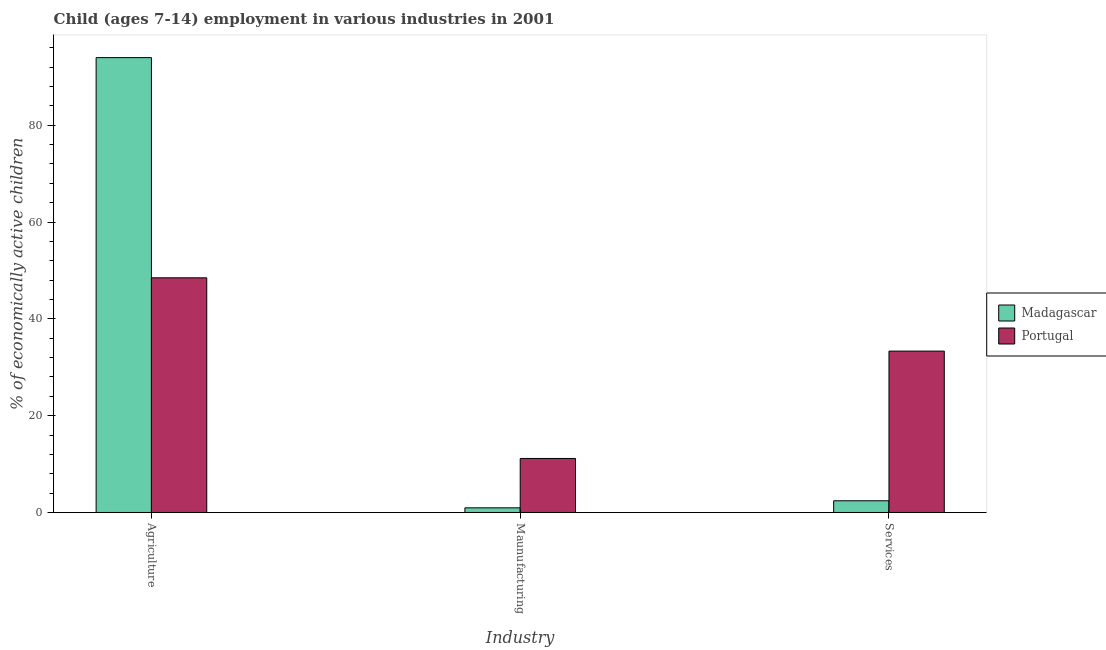How many different coloured bars are there?
Ensure brevity in your answer.  2. How many groups of bars are there?
Your response must be concise. 3. Are the number of bars per tick equal to the number of legend labels?
Provide a short and direct response. Yes. Are the number of bars on each tick of the X-axis equal?
Your answer should be very brief. Yes. How many bars are there on the 1st tick from the right?
Provide a succinct answer. 2. What is the label of the 3rd group of bars from the left?
Keep it short and to the point. Services. What is the percentage of economically active children in services in Madagascar?
Provide a succinct answer. 2.42. Across all countries, what is the maximum percentage of economically active children in manufacturing?
Provide a succinct answer. 11.16. Across all countries, what is the minimum percentage of economically active children in agriculture?
Offer a terse response. 48.48. In which country was the percentage of economically active children in manufacturing maximum?
Your response must be concise. Portugal. In which country was the percentage of economically active children in services minimum?
Your answer should be compact. Madagascar. What is the total percentage of economically active children in manufacturing in the graph?
Your answer should be compact. 12.12. What is the difference between the percentage of economically active children in agriculture in Portugal and that in Madagascar?
Give a very brief answer. -45.49. What is the difference between the percentage of economically active children in services in Madagascar and the percentage of economically active children in agriculture in Portugal?
Ensure brevity in your answer.  -46.06. What is the average percentage of economically active children in manufacturing per country?
Your response must be concise. 6.06. What is the difference between the percentage of economically active children in agriculture and percentage of economically active children in services in Portugal?
Give a very brief answer. 15.14. In how many countries, is the percentage of economically active children in manufacturing greater than 80 %?
Your response must be concise. 0. What is the ratio of the percentage of economically active children in manufacturing in Portugal to that in Madagascar?
Give a very brief answer. 11.62. What is the difference between the highest and the second highest percentage of economically active children in agriculture?
Provide a short and direct response. 45.49. What is the difference between the highest and the lowest percentage of economically active children in services?
Keep it short and to the point. 30.92. Is the sum of the percentage of economically active children in agriculture in Madagascar and Portugal greater than the maximum percentage of economically active children in services across all countries?
Offer a very short reply. Yes. What does the 2nd bar from the left in Maunufacturing represents?
Provide a short and direct response. Portugal. What does the 2nd bar from the right in Agriculture represents?
Make the answer very short. Madagascar. How many bars are there?
Give a very brief answer. 6. Are all the bars in the graph horizontal?
Your answer should be compact. No. What is the difference between two consecutive major ticks on the Y-axis?
Your answer should be compact. 20. Are the values on the major ticks of Y-axis written in scientific E-notation?
Give a very brief answer. No. Does the graph contain any zero values?
Provide a short and direct response. No. Does the graph contain grids?
Give a very brief answer. No. Where does the legend appear in the graph?
Provide a short and direct response. Center right. How many legend labels are there?
Keep it short and to the point. 2. What is the title of the graph?
Offer a very short reply. Child (ages 7-14) employment in various industries in 2001. What is the label or title of the X-axis?
Your answer should be very brief. Industry. What is the label or title of the Y-axis?
Provide a short and direct response. % of economically active children. What is the % of economically active children of Madagascar in Agriculture?
Offer a very short reply. 93.97. What is the % of economically active children of Portugal in Agriculture?
Your answer should be very brief. 48.48. What is the % of economically active children of Portugal in Maunufacturing?
Your response must be concise. 11.16. What is the % of economically active children in Madagascar in Services?
Make the answer very short. 2.42. What is the % of economically active children of Portugal in Services?
Your answer should be compact. 33.34. Across all Industry, what is the maximum % of economically active children of Madagascar?
Give a very brief answer. 93.97. Across all Industry, what is the maximum % of economically active children in Portugal?
Make the answer very short. 48.48. Across all Industry, what is the minimum % of economically active children of Portugal?
Your response must be concise. 11.16. What is the total % of economically active children of Madagascar in the graph?
Ensure brevity in your answer.  97.35. What is the total % of economically active children of Portugal in the graph?
Provide a short and direct response. 92.98. What is the difference between the % of economically active children of Madagascar in Agriculture and that in Maunufacturing?
Give a very brief answer. 93.01. What is the difference between the % of economically active children of Portugal in Agriculture and that in Maunufacturing?
Provide a short and direct response. 37.32. What is the difference between the % of economically active children in Madagascar in Agriculture and that in Services?
Offer a terse response. 91.55. What is the difference between the % of economically active children of Portugal in Agriculture and that in Services?
Give a very brief answer. 15.14. What is the difference between the % of economically active children of Madagascar in Maunufacturing and that in Services?
Your answer should be compact. -1.46. What is the difference between the % of economically active children in Portugal in Maunufacturing and that in Services?
Your response must be concise. -22.18. What is the difference between the % of economically active children in Madagascar in Agriculture and the % of economically active children in Portugal in Maunufacturing?
Your answer should be very brief. 82.81. What is the difference between the % of economically active children of Madagascar in Agriculture and the % of economically active children of Portugal in Services?
Provide a succinct answer. 60.63. What is the difference between the % of economically active children of Madagascar in Maunufacturing and the % of economically active children of Portugal in Services?
Offer a terse response. -32.38. What is the average % of economically active children in Madagascar per Industry?
Give a very brief answer. 32.45. What is the average % of economically active children in Portugal per Industry?
Keep it short and to the point. 30.99. What is the difference between the % of economically active children in Madagascar and % of economically active children in Portugal in Agriculture?
Your answer should be compact. 45.49. What is the difference between the % of economically active children in Madagascar and % of economically active children in Portugal in Maunufacturing?
Offer a terse response. -10.2. What is the difference between the % of economically active children of Madagascar and % of economically active children of Portugal in Services?
Offer a terse response. -30.92. What is the ratio of the % of economically active children in Madagascar in Agriculture to that in Maunufacturing?
Offer a terse response. 97.89. What is the ratio of the % of economically active children in Portugal in Agriculture to that in Maunufacturing?
Provide a short and direct response. 4.34. What is the ratio of the % of economically active children of Madagascar in Agriculture to that in Services?
Offer a terse response. 38.83. What is the ratio of the % of economically active children of Portugal in Agriculture to that in Services?
Your response must be concise. 1.45. What is the ratio of the % of economically active children in Madagascar in Maunufacturing to that in Services?
Keep it short and to the point. 0.4. What is the ratio of the % of economically active children of Portugal in Maunufacturing to that in Services?
Your answer should be very brief. 0.33. What is the difference between the highest and the second highest % of economically active children of Madagascar?
Keep it short and to the point. 91.55. What is the difference between the highest and the second highest % of economically active children in Portugal?
Your answer should be compact. 15.14. What is the difference between the highest and the lowest % of economically active children in Madagascar?
Offer a very short reply. 93.01. What is the difference between the highest and the lowest % of economically active children of Portugal?
Keep it short and to the point. 37.32. 